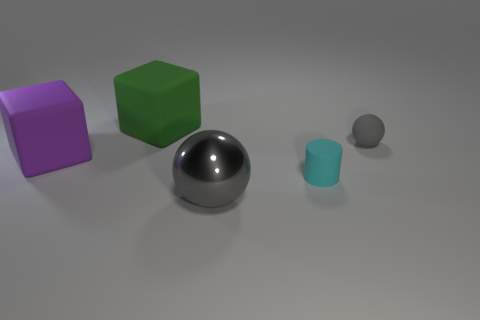Can you describe the texture of the balls and blocks? Certainly! The large shiny ball has a smooth and reflective surface, creating a mirror-like effect. On the other hand, the small matte ball appears to have a diffuse, non-reflective surface. The blocks also seem to have a matte finish, with the light diffusely reflecting off their surfaces, indicating a lack of glossiness. 